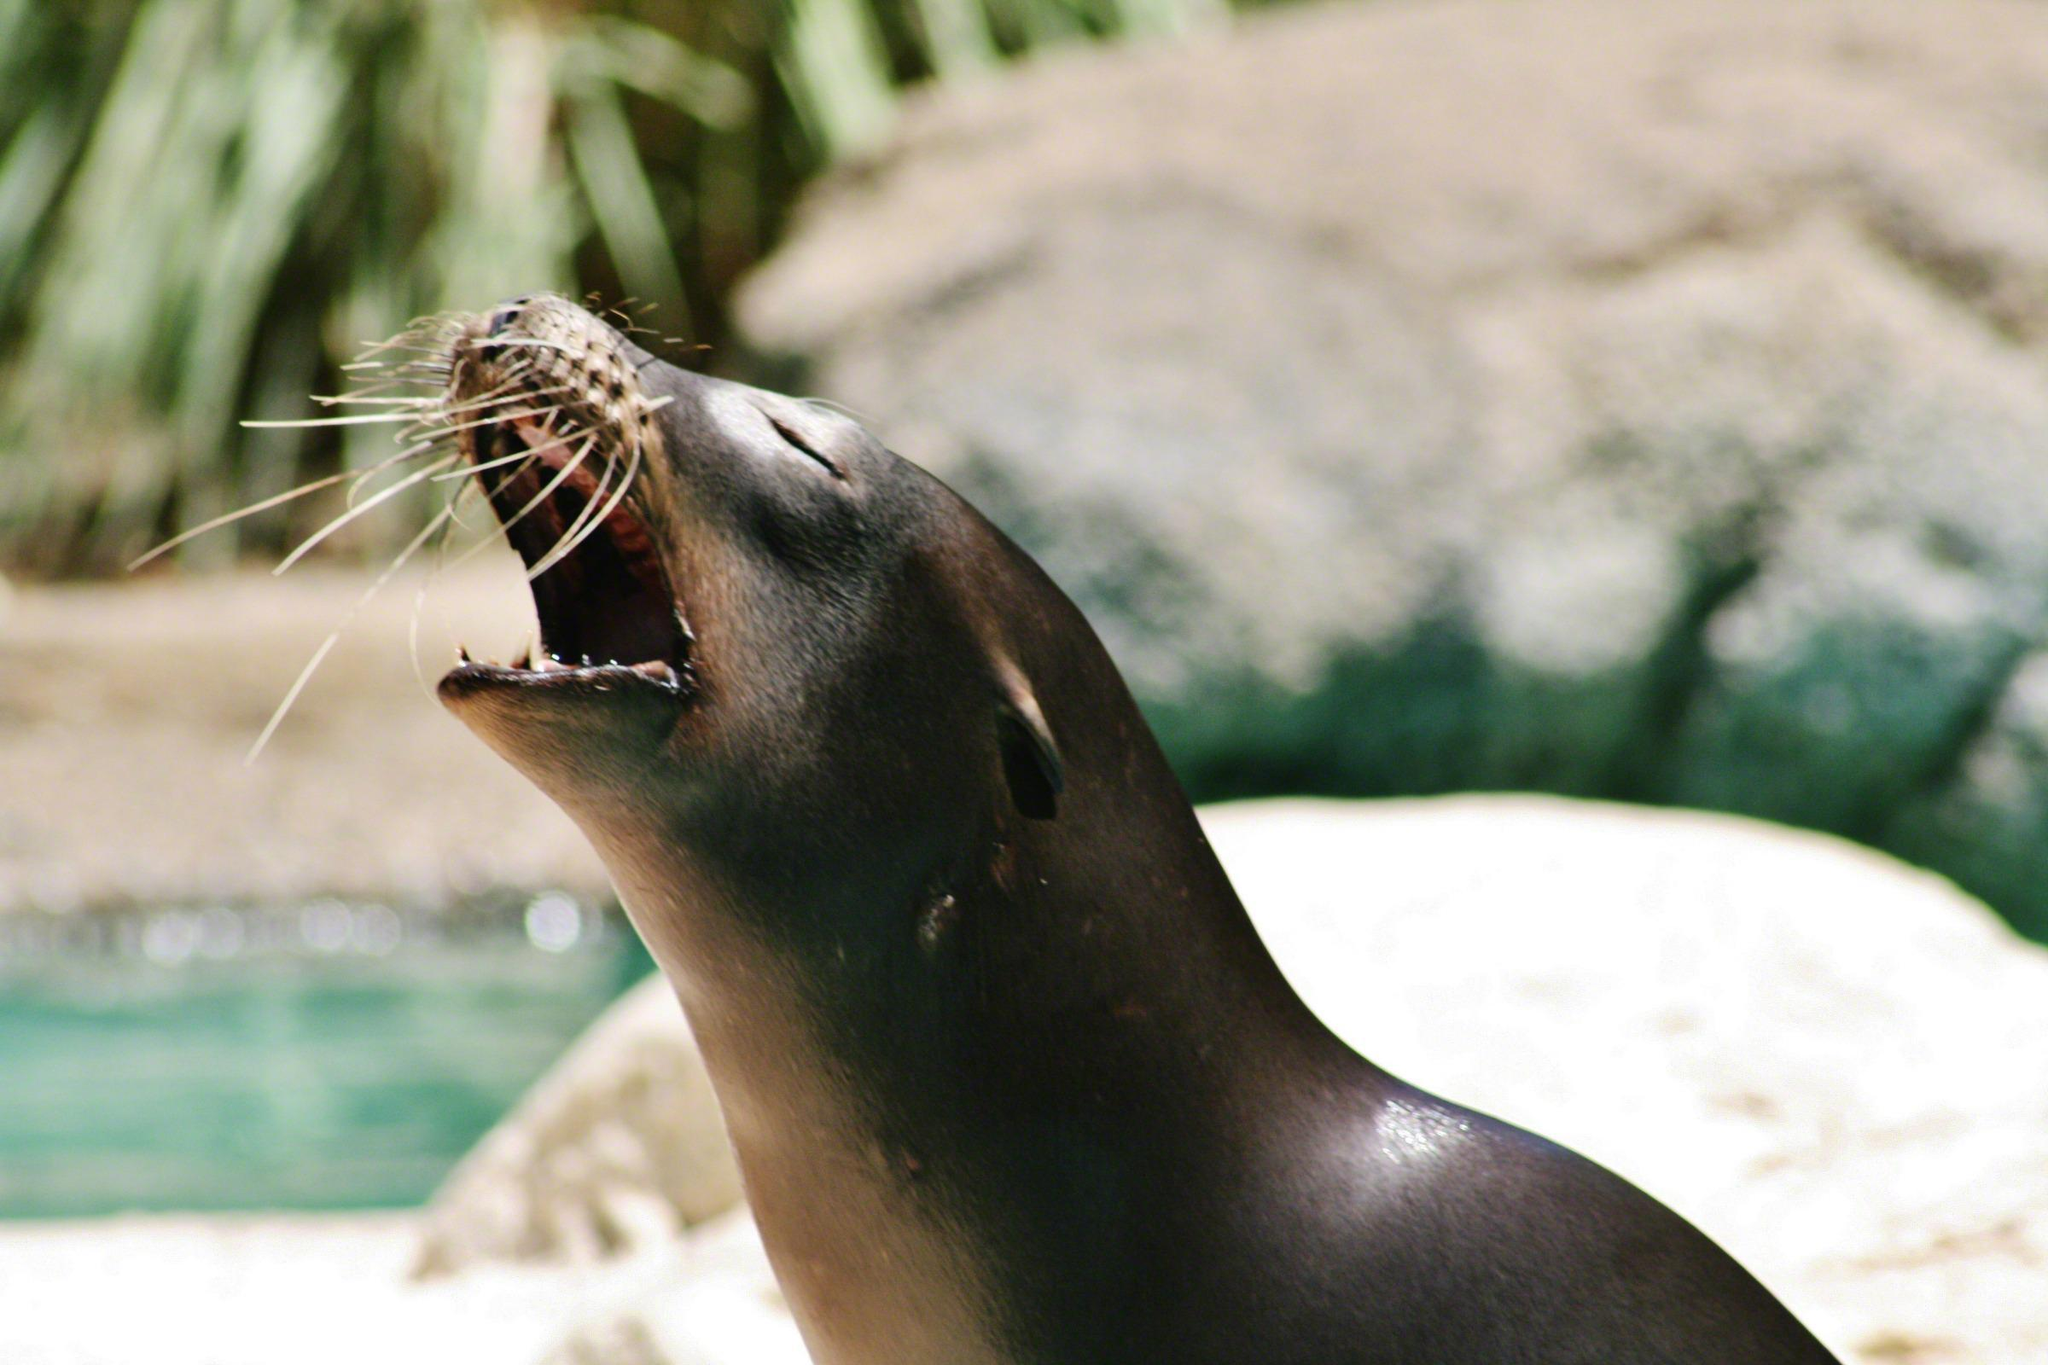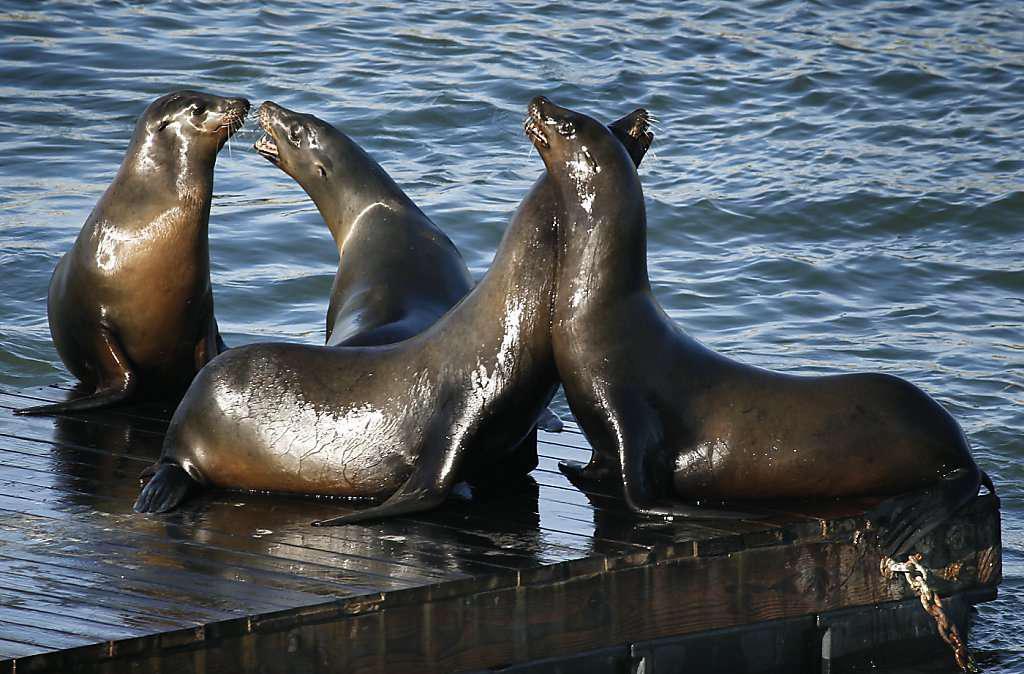The first image is the image on the left, the second image is the image on the right. Considering the images on both sides, is "An image includes a seal in the foreground with its mouth open and head upside-down." valid? Answer yes or no. No. The first image is the image on the left, the second image is the image on the right. Examine the images to the left and right. Is the description "There are more seals in the image on the right." accurate? Answer yes or no. Yes. 